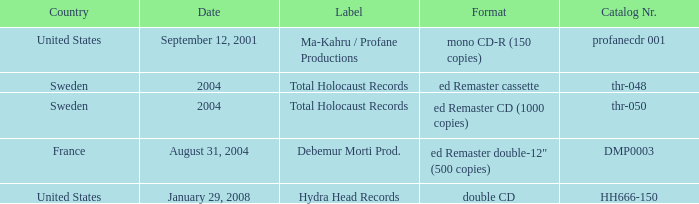From which country does the debemur morti productions label originate? France. Write the full table. {'header': ['Country', 'Date', 'Label', 'Format', 'Catalog Nr.'], 'rows': [['United States', 'September 12, 2001', 'Ma-Kahru / Profane Productions', 'mono CD-R (150 copies)', 'profanecdr 001'], ['Sweden', '2004', 'Total Holocaust Records', 'ed Remaster cassette', 'thr-048'], ['Sweden', '2004', 'Total Holocaust Records', 'ed Remaster CD (1000 copies)', 'thr-050'], ['France', 'August 31, 2004', 'Debemur Morti Prod.', 'ed Remaster double-12" (500 copies)', 'DMP0003'], ['United States', 'January 29, 2008', 'Hydra Head Records', 'double CD', 'HH666-150']]} 